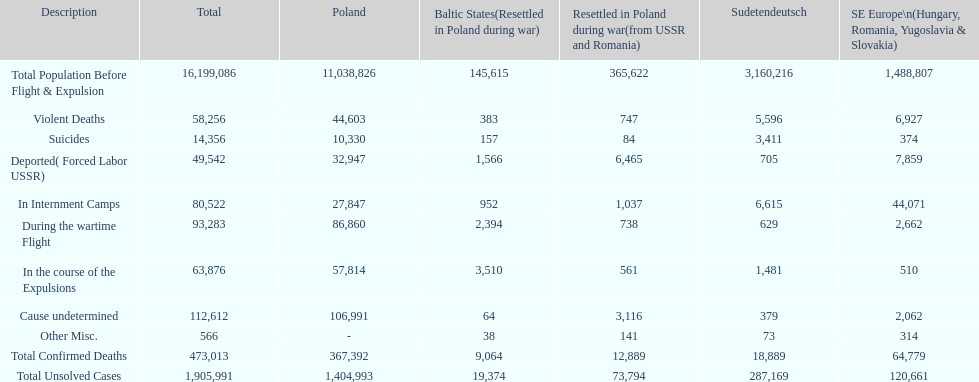How do suicides in poland and sudetendeutsch differ? 6919. 